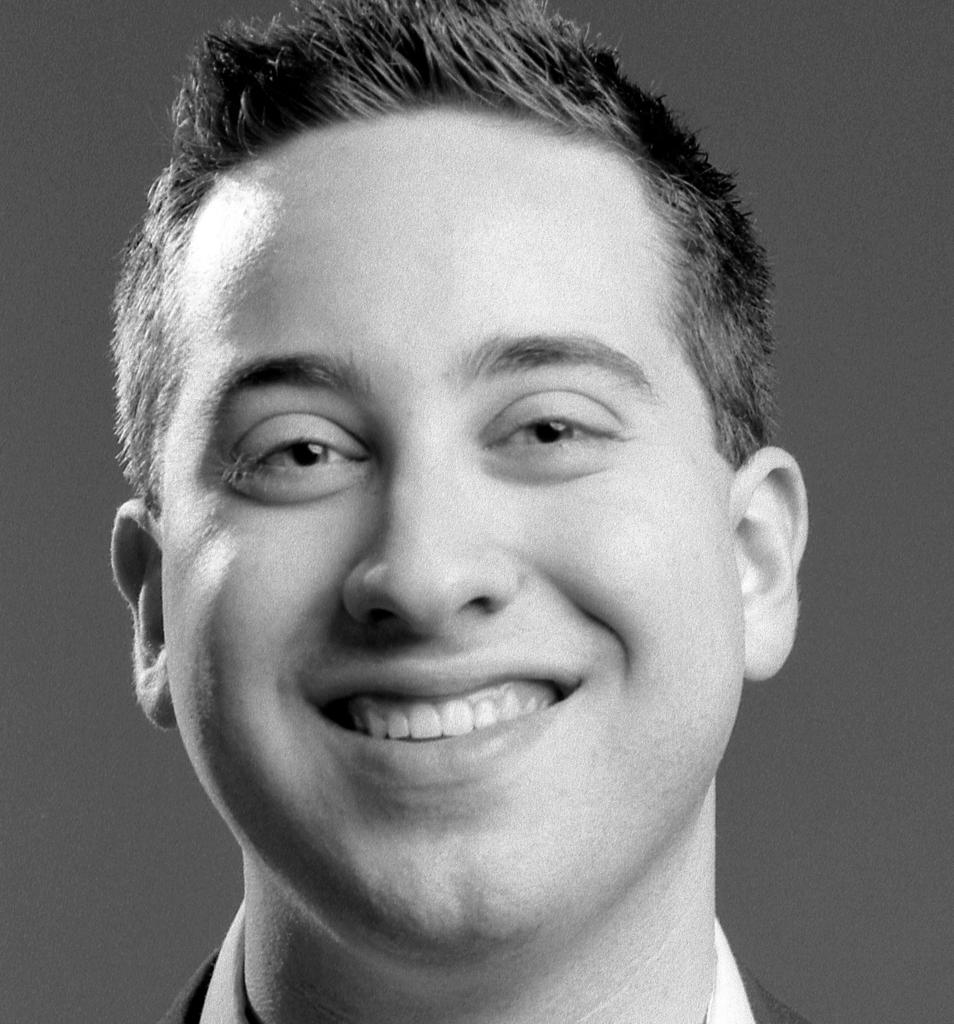What is the color scheme of the image? The image is black and white. What is the main subject of the image? There is a man in the image. What is the man doing in the image? The man is smiling. Can you see the man swinging on a swing in the image? There is no swing or any indication of the man swinging in the image. What type of lipstick is the man wearing in the image? The man is not wearing any lipstick in the image. 